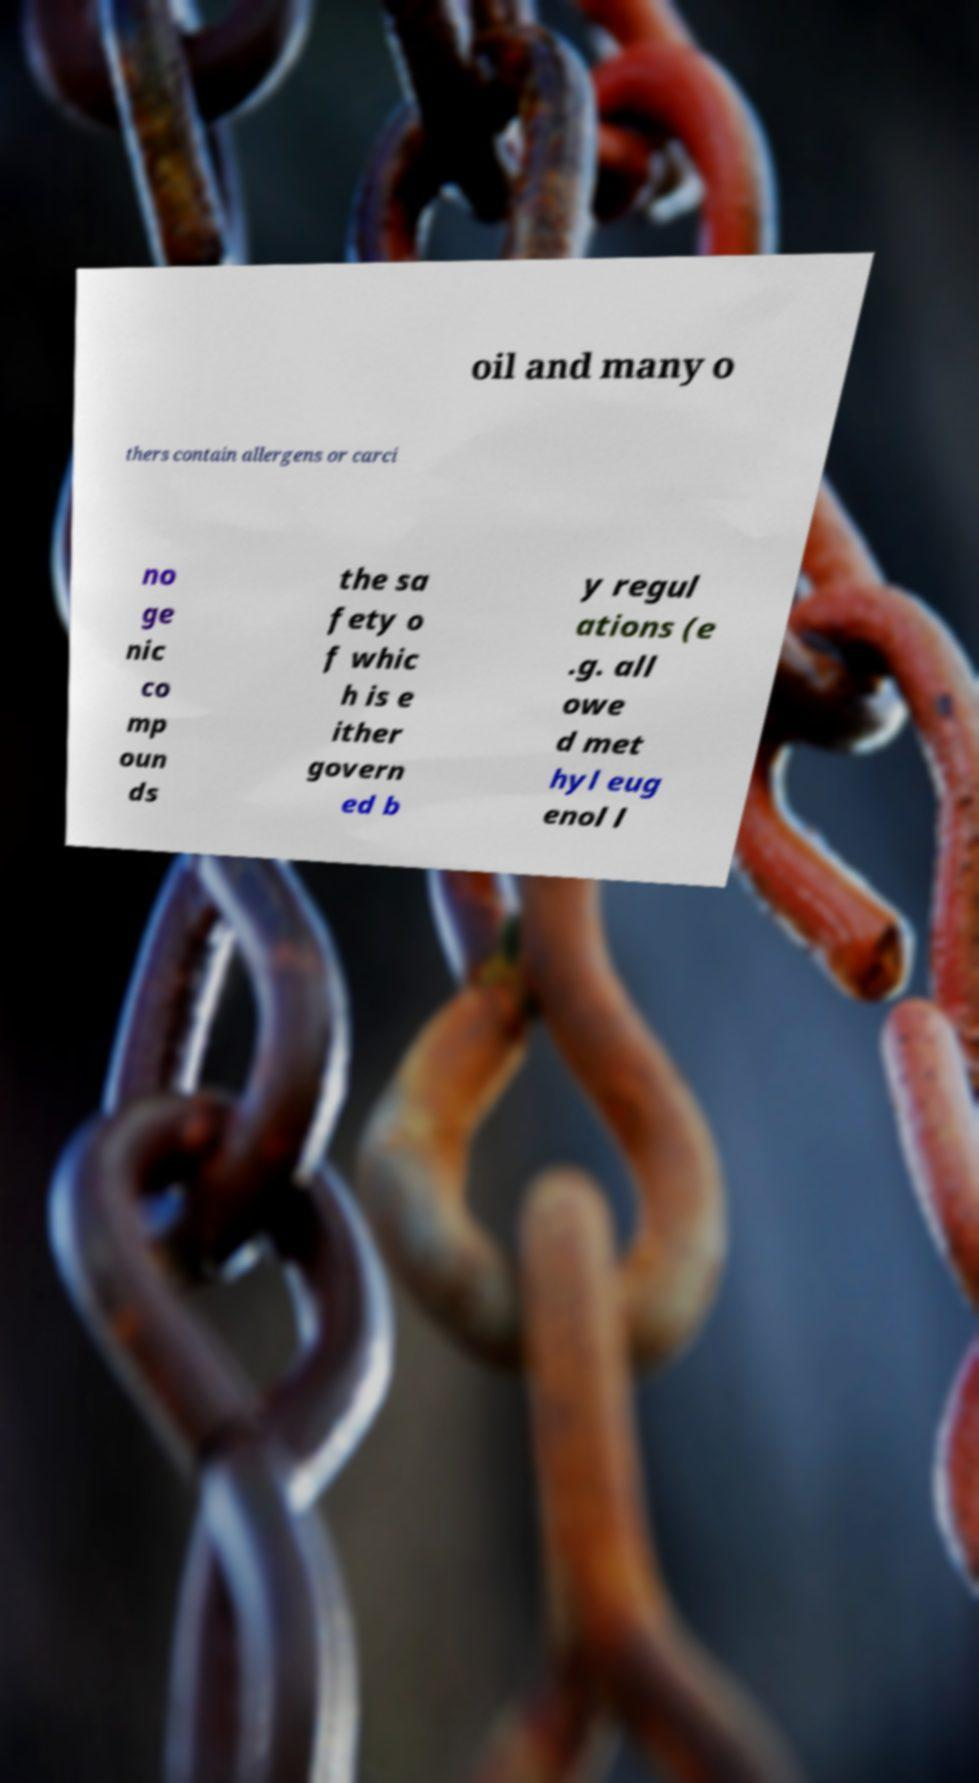I need the written content from this picture converted into text. Can you do that? oil and many o thers contain allergens or carci no ge nic co mp oun ds the sa fety o f whic h is e ither govern ed b y regul ations (e .g. all owe d met hyl eug enol l 